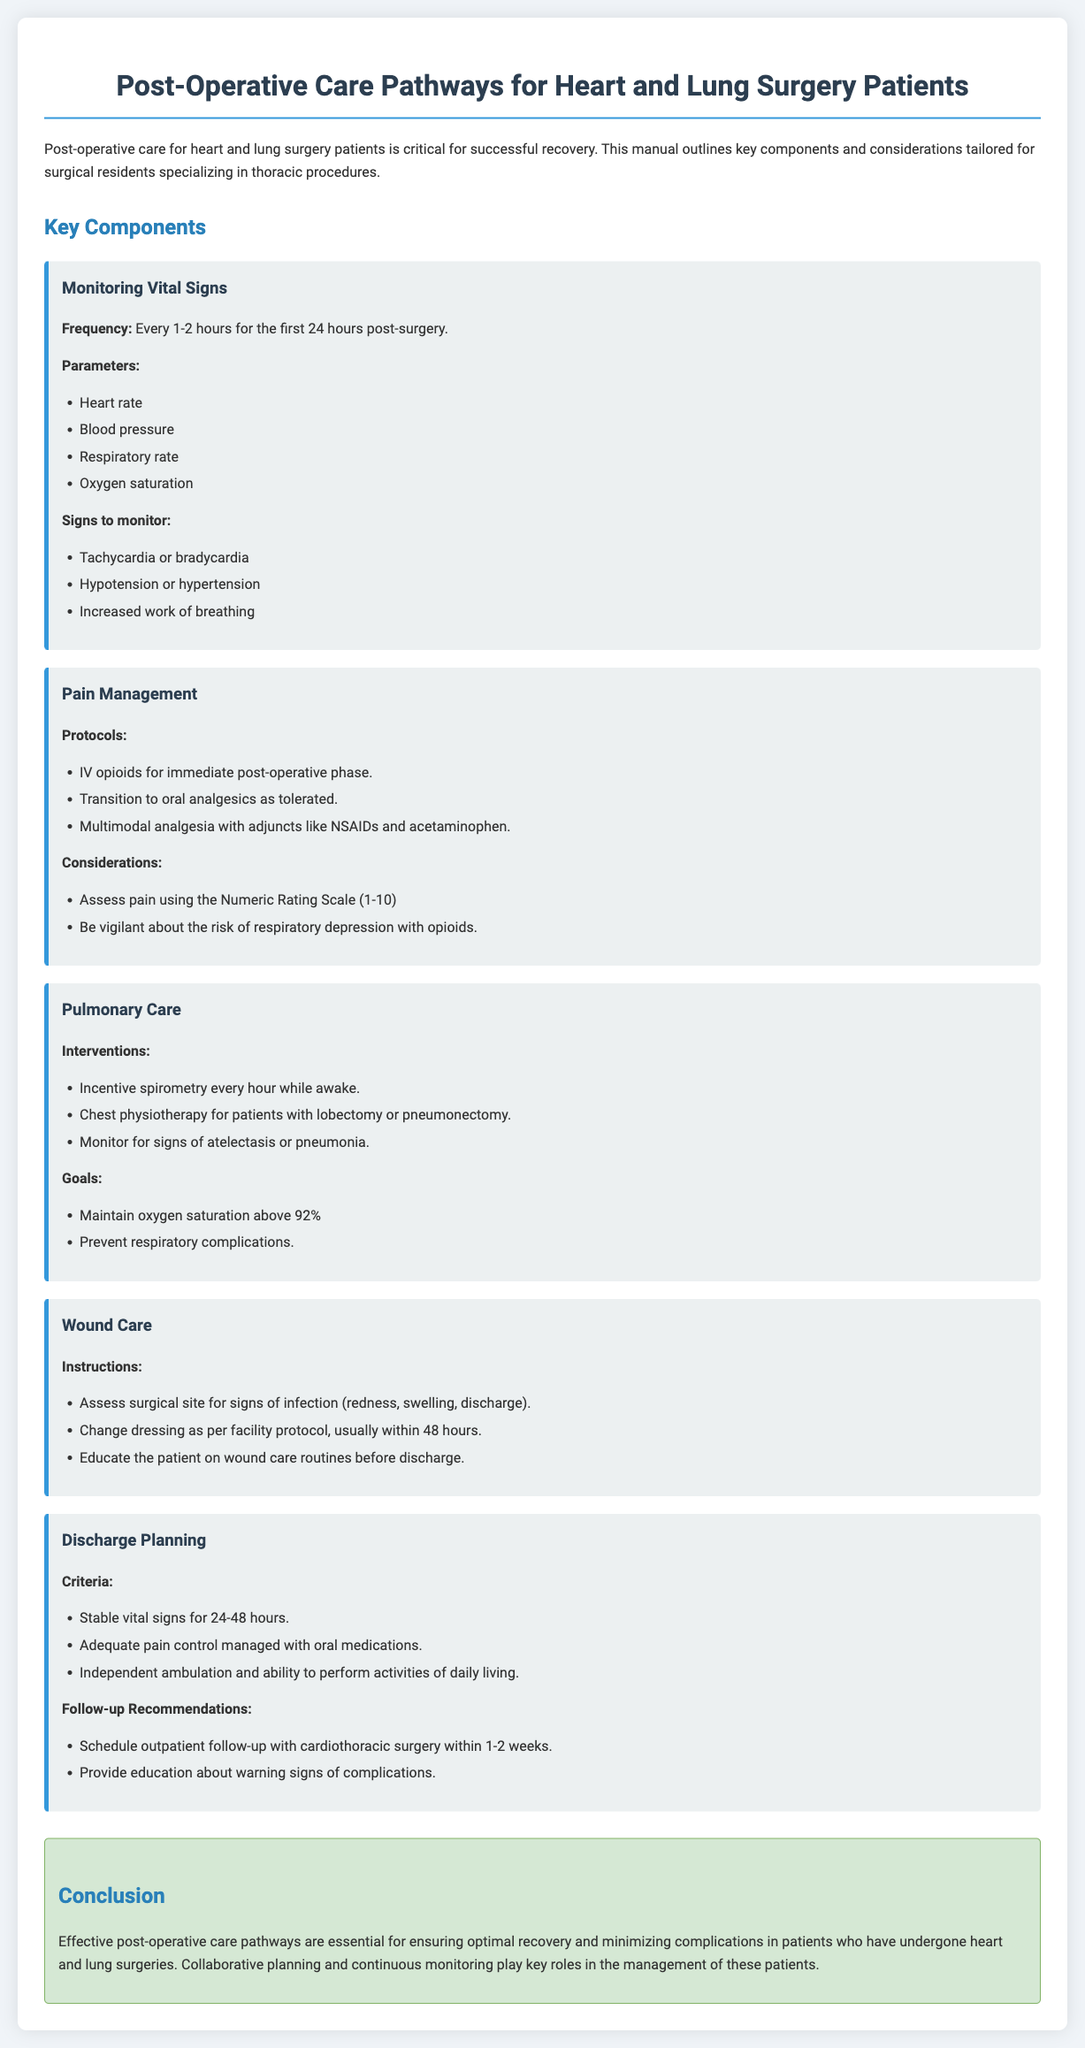What is the frequency for monitoring vital signs? The document states that vital signs should be monitored every 1-2 hours for the first 24 hours post-surgery.
Answer: Every 1-2 hours What are the vital signs to monitor? The document includes heart rate, blood pressure, respiratory rate, and oxygen saturation as vital signs to monitor.
Answer: Heart rate, blood pressure, respiratory rate, oxygen saturation What types of pain management protocols are mentioned? The document lists IV opioids, transition to oral analgesics, and multimodal analgesia with adjuncts as pain management protocols.
Answer: IV opioids, oral analgesics, multimodal analgesia What is the goal for oxygen saturation? The document specifies that the goal is to maintain oxygen saturation above 92%.
Answer: Above 92% What are the discharge criteria? The criteria for discharge include stable vital signs, adequate pain control, and independent ambulation.
Answer: Stable vital signs, adequate pain control, independent ambulation How often should incentive spirometry be performed? The document states that incentive spirometry should be performed every hour while awake.
Answer: Every hour while awake What is a sign of infection to look for in wound care? The document notes that redness, swelling, or discharge are signs of infection to monitor.
Answer: Redness, swelling, discharge What is recommended for follow-up after discharge? The document recommends scheduling an outpatient follow-up within 1-2 weeks.
Answer: Within 1-2 weeks 